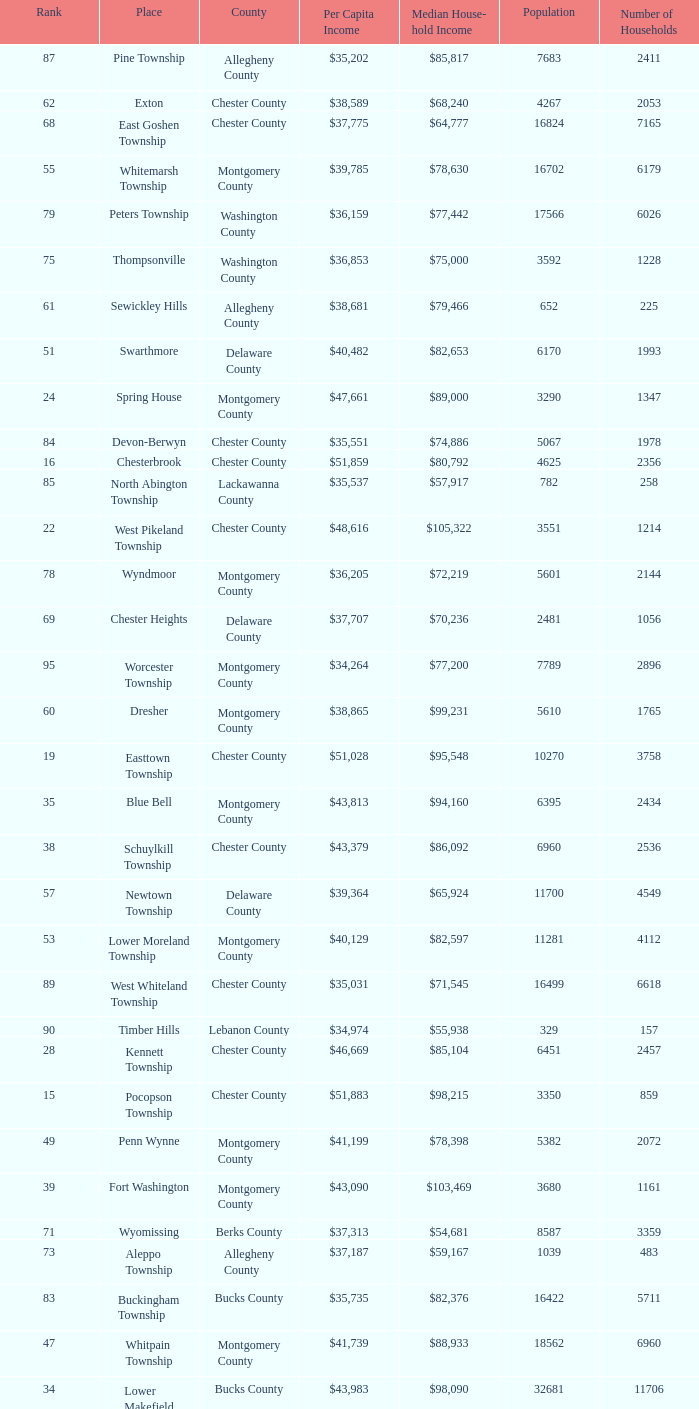What is the median household income for Woodside? $121,151. 